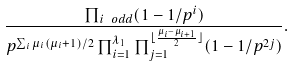Convert formula to latex. <formula><loc_0><loc_0><loc_500><loc_500>\frac { \prod _ { i \ o d d } ( 1 - 1 / p ^ { i } ) } { p ^ { \sum _ { i } \mu _ { i } ( \mu _ { i } + 1 ) / 2 } \prod _ { i = 1 } ^ { \lambda _ { 1 } } \prod _ { j = 1 } ^ { \lfloor \frac { \mu _ { i } - \mu _ { i + 1 } } { 2 } \rfloor } ( 1 - 1 / p ^ { 2 j } ) } .</formula> 